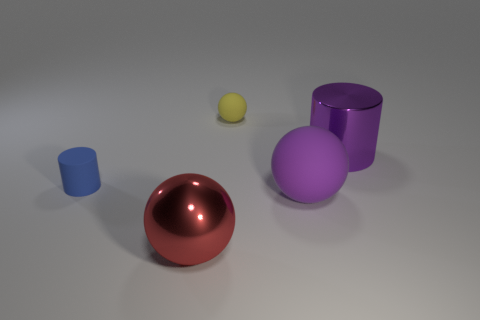How big is the rubber object that is on the left side of the big sphere that is in front of the large purple ball?
Your answer should be very brief. Small. What is the color of the large thing that is right of the sphere that is to the right of the tiny yellow sphere that is on the right side of the small blue matte object?
Offer a very short reply. Purple. There is a object that is behind the tiny blue cylinder and in front of the yellow rubber ball; how big is it?
Make the answer very short. Large. How many other objects are there of the same shape as the big matte object?
Your response must be concise. 2. How many spheres are small yellow objects or blue matte objects?
Offer a terse response. 1. There is a large object to the left of the small object that is on the right side of the big red sphere; is there a large red object in front of it?
Give a very brief answer. No. What is the color of the other rubber thing that is the same shape as the tiny yellow object?
Offer a very short reply. Purple. What number of purple objects are matte spheres or small metal cubes?
Offer a very short reply. 1. There is a cylinder on the left side of the purple rubber sphere that is in front of the purple shiny object; what is its material?
Ensure brevity in your answer.  Rubber. Is the small blue rubber object the same shape as the tiny yellow thing?
Ensure brevity in your answer.  No. 